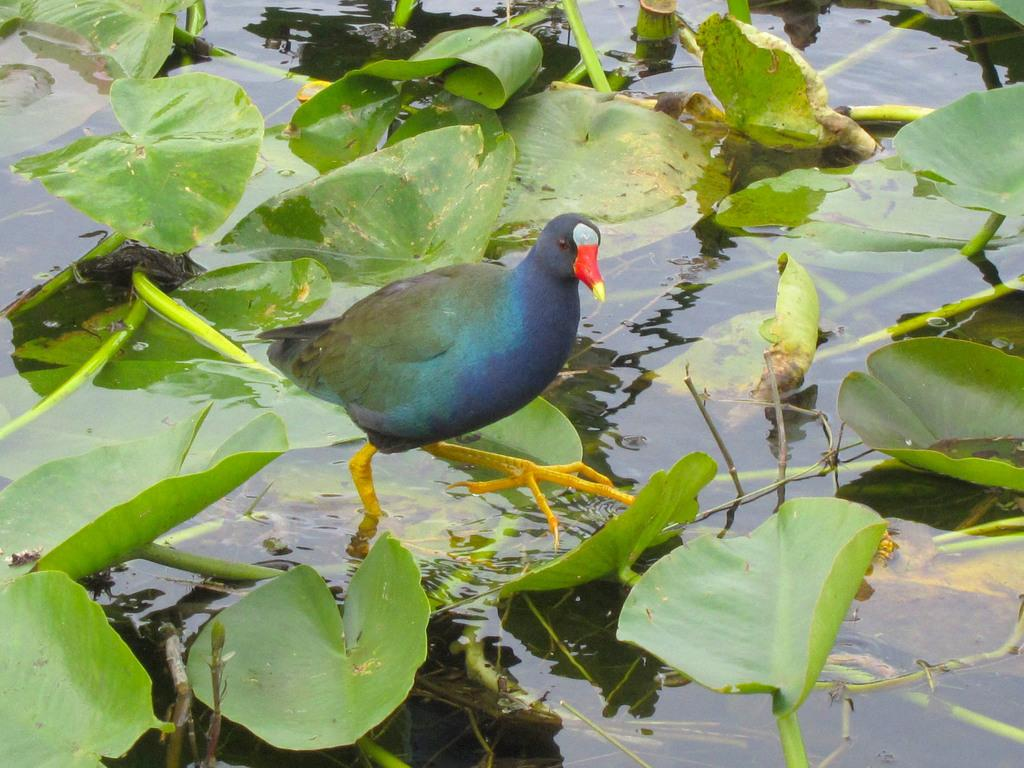What type of animal can be seen in the water in the image? There is a bird in the water in the image. What else can be seen floating on the water? Green leaves are floating on the water. What grade did the bird receive for its invention in the image? There is no mention of a grade or an invention in the image; it simply shows a bird in the water and green leaves floating on the water. 